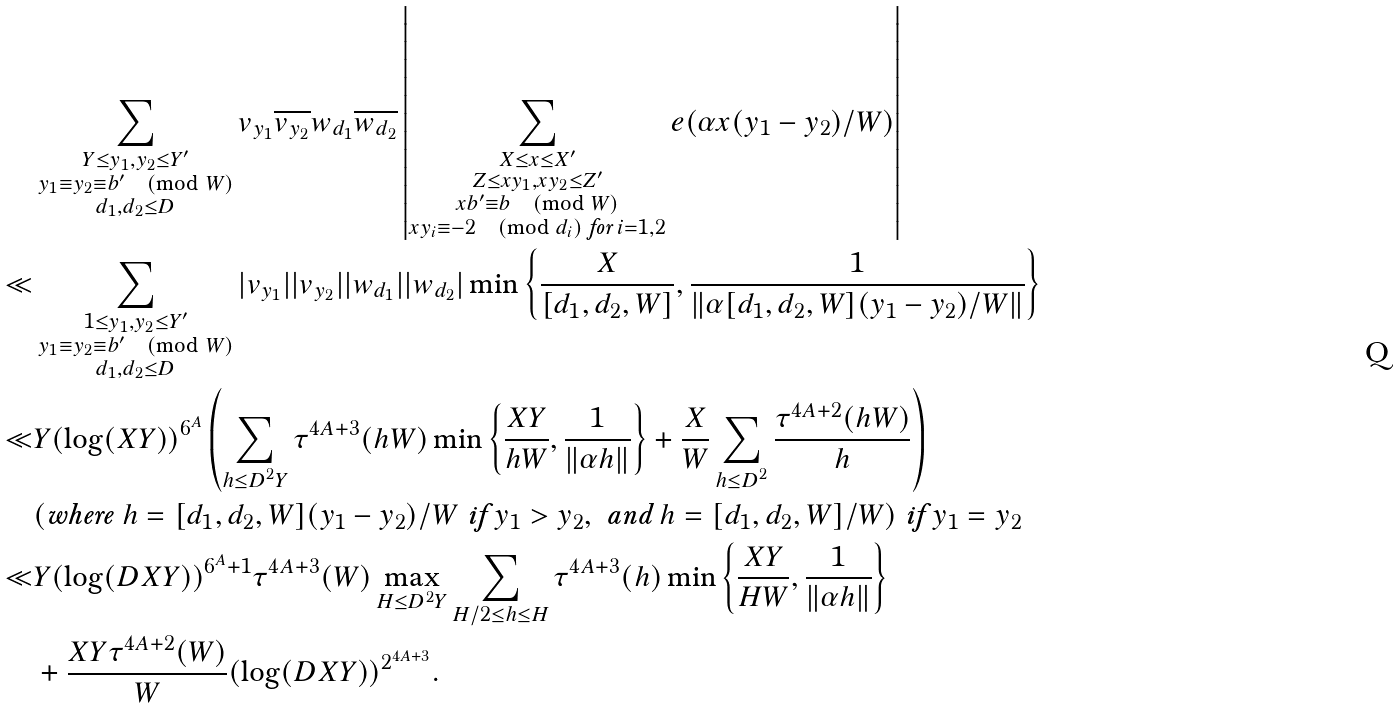Convert formula to latex. <formula><loc_0><loc_0><loc_500><loc_500>& \sum _ { \substack { Y \leq y _ { 1 } , y _ { 2 } \leq Y ^ { \prime } \\ y _ { 1 } \equiv y _ { 2 } \equiv b ^ { \prime } \pmod { W } \\ d _ { 1 } , d _ { 2 } \leq D } } v _ { y _ { 1 } } \overline { v _ { y _ { 2 } } } w _ { d _ { 1 } } \overline { w _ { d _ { 2 } } } \left | \sum _ { \substack { X \leq x \leq X ^ { \prime } \\ Z \leq x y _ { 1 } , x y _ { 2 } \leq Z ^ { \prime } \\ x b ^ { \prime } \equiv b \pmod { W } \\ x y _ { i } \equiv - 2 \pmod { d _ { i } } \text { for } i = 1 , 2 } } e ( \alpha x ( y _ { 1 } - y _ { 2 } ) / W ) \right | \\ \ll & \sum _ { \substack { 1 \leq y _ { 1 } , y _ { 2 } \leq Y ^ { \prime } \\ y _ { 1 } \equiv y _ { 2 } \equiv b ^ { \prime } \pmod { W } \\ d _ { 1 } , d _ { 2 } \leq D } } | v _ { y _ { 1 } } | | v _ { y _ { 2 } } | | w _ { d _ { 1 } } | | w _ { d _ { 2 } } | \min \left \{ \frac { X } { [ d _ { 1 } , d _ { 2 } , W ] } , \frac { 1 } { \| \alpha [ d _ { 1 } , d _ { 2 } , W ] ( y _ { 1 } - y _ { 2 } ) / W \| } \right \} \\ \ll & Y ( \log ( X Y ) ) ^ { 6 ^ { A } } \left ( \sum _ { \substack { h \leq D ^ { 2 } Y } } \tau ^ { 4 A + 3 } ( h W ) \min \left \{ \frac { X Y } { h W } , \frac { 1 } { \| \alpha h \| } \right \} + \frac { X } { W } \sum _ { \substack { h \leq D ^ { 2 } } } \frac { \tau ^ { 4 A + 2 } ( h W ) } { h } \right ) \\ & ( \text {where } h = [ d _ { 1 } , d _ { 2 } , W ] ( y _ { 1 } - y _ { 2 } ) / W \text { if } y _ { 1 } > y _ { 2 } , \text { and } h = [ d _ { 1 } , d _ { 2 } , W ] / W ) \text { if } y _ { 1 } = y _ { 2 } \\ \ll & Y ( \log ( D X Y ) ) ^ { 6 ^ { A } + 1 } \tau ^ { 4 A + 3 } ( W ) \max _ { H \leq D ^ { 2 } Y } \sum _ { \substack { H / 2 \leq h \leq H } } \tau ^ { 4 A + 3 } ( h ) \min \left \{ \frac { X Y } { H W } , \frac { 1 } { \| \alpha h \| } \right \} \\ & + \frac { X Y \tau ^ { 4 A + 2 } ( W ) } { W } ( \log ( D X Y ) ) ^ { 2 ^ { 4 A + 3 } } .</formula> 